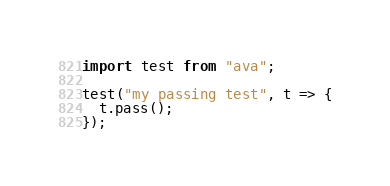Convert code to text. <code><loc_0><loc_0><loc_500><loc_500><_JavaScript_>import test from "ava";

test("my passing test", t => {
  t.pass();
});
</code> 